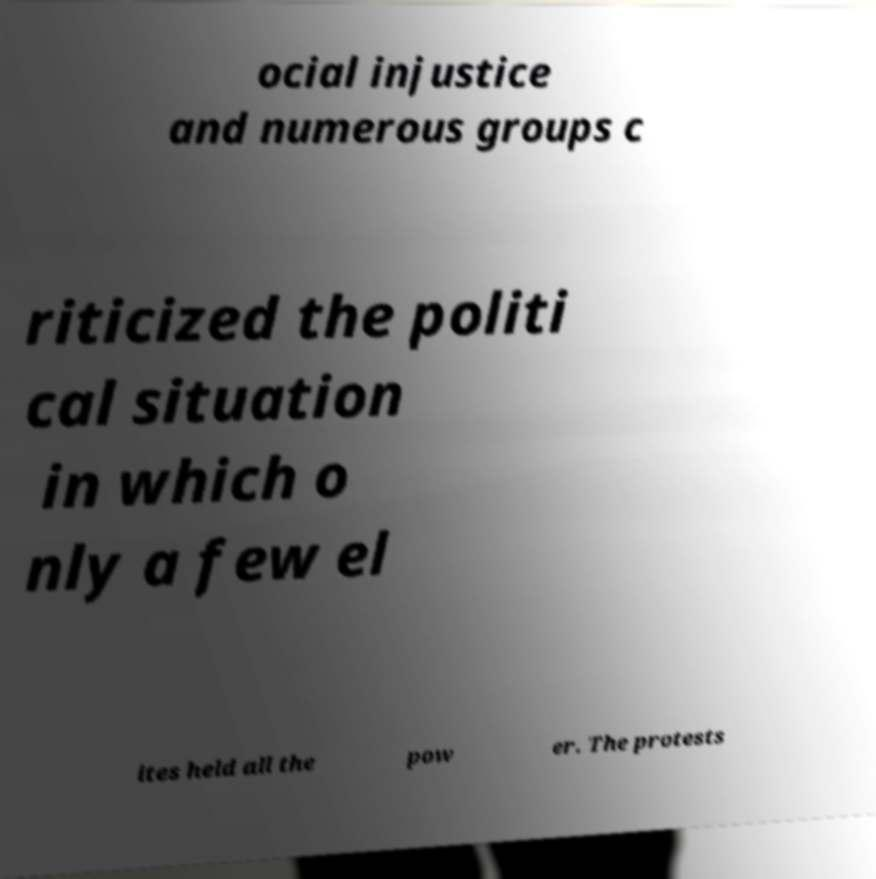Could you extract and type out the text from this image? ocial injustice and numerous groups c riticized the politi cal situation in which o nly a few el ites held all the pow er. The protests 